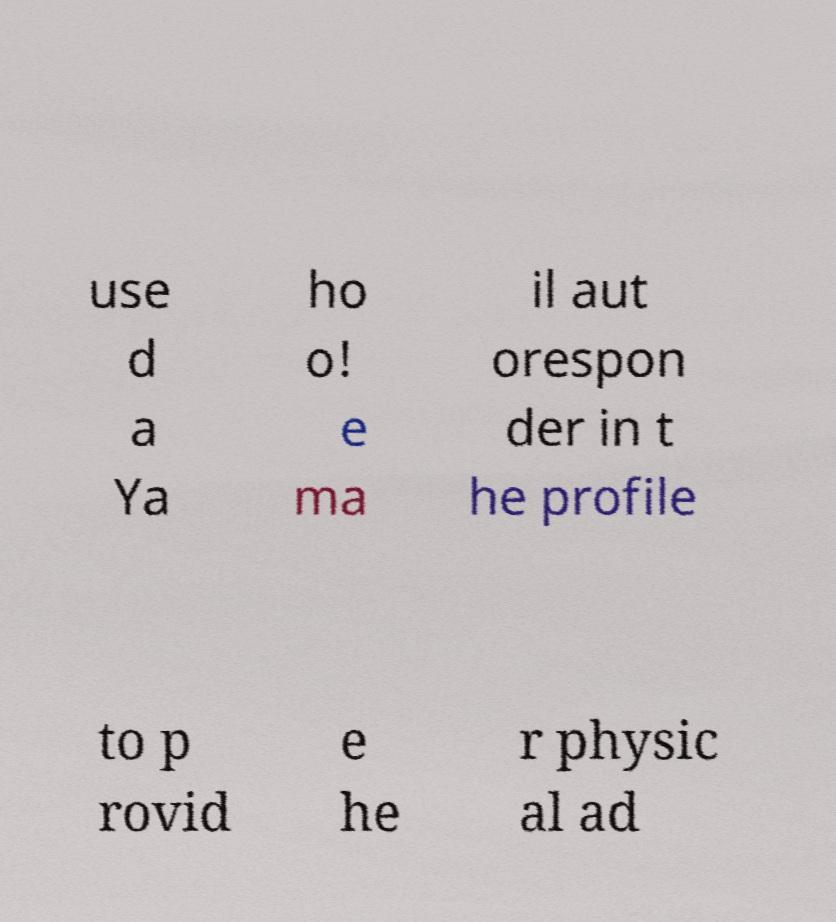Can you read and provide the text displayed in the image?This photo seems to have some interesting text. Can you extract and type it out for me? use d a Ya ho o! e ma il aut orespon der in t he profile to p rovid e he r physic al ad 